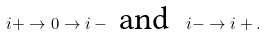<formula> <loc_0><loc_0><loc_500><loc_500>i + \to 0 \to i - \ \text {and} \ \ i - \to i + .</formula> 